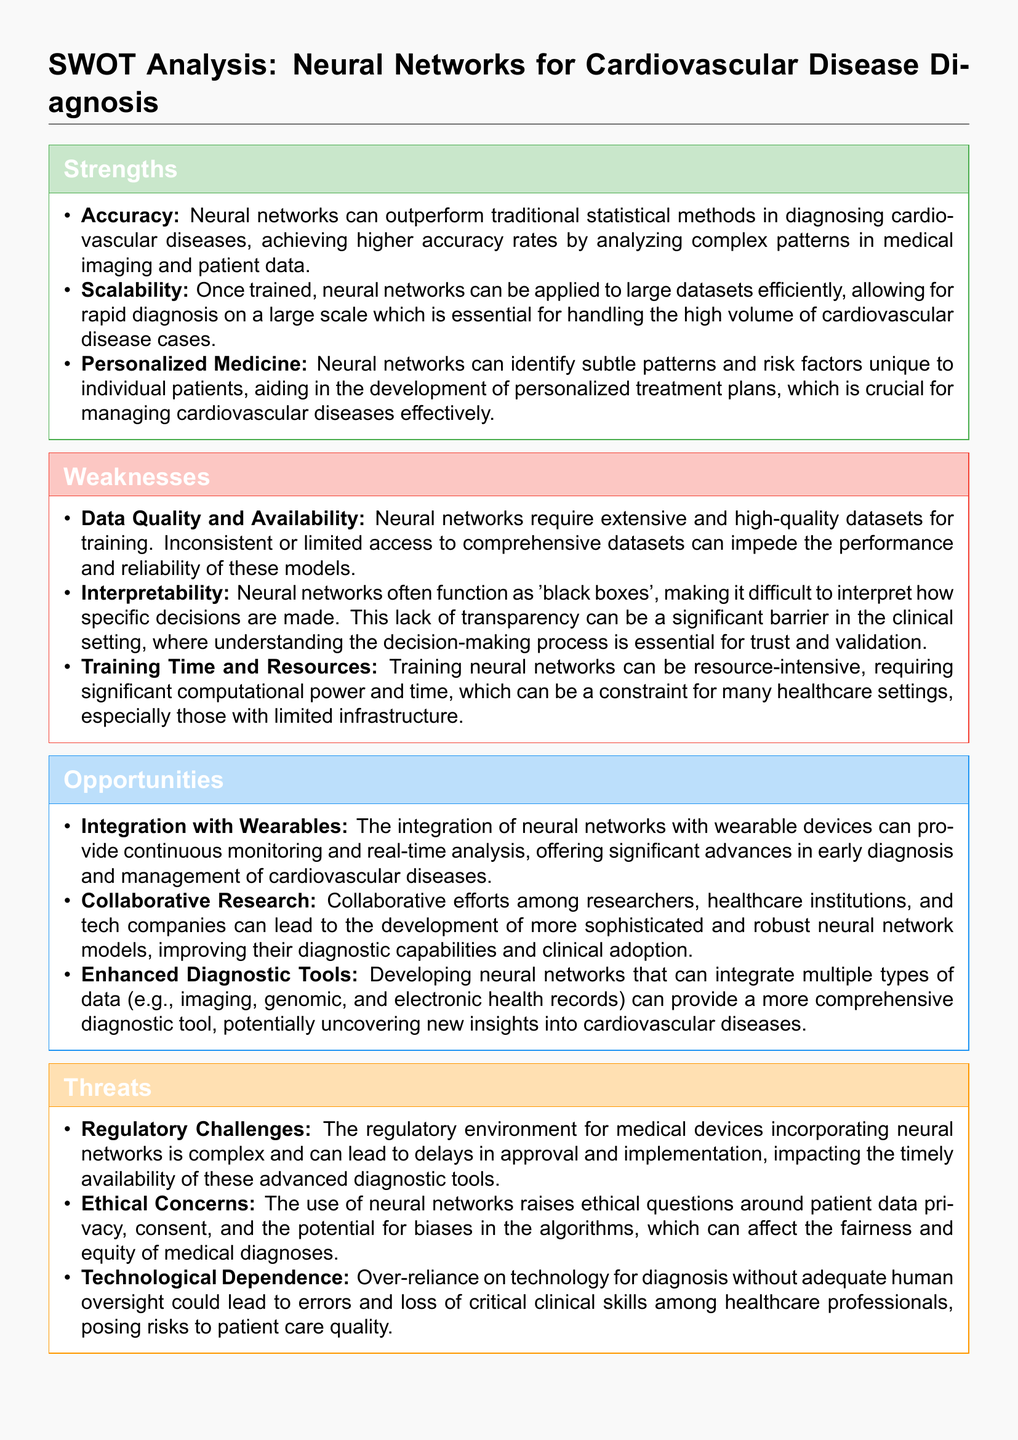What are two strengths of neural networks in cardiovascular disease diagnosis? The strengths listed under the "Strengths" section are accuracy and scalability, which can be retrieved directly from the document.
Answer: accuracy, scalability What is one weakness related to the data used for training neural networks? The document states that data quality and availability are weaknesses, highlighting a need for extensive and high-quality datasets.
Answer: Data Quality and Availability What opportunity is mentioned that involves wearable devices? The document mentions the integration with wearables as an opportunity for continuous monitoring and real-time analysis.
Answer: Integration with Wearables What is the threat associated with patient data in the use of neural networks? The document highlights ethical concerns regarding patient data privacy as a threat.
Answer: Ethical Concerns How many strengths are listed in total? The "Strengths" section of the document lists three strengths of neural networks for diagnosis.
Answer: 3 What is the potential impact of regulatory challenges as mentioned in the document? Regulatory challenges can lead to delays in approval and implementation of diagnostic tools.
Answer: Delays in approval What aspect of decision-making does the weakness of interpretability address? The weakness of interpretability highlights that neural networks can be 'black boxes,' making it difficult to understand their decision-making process.
Answer: Understanding the decision-making process What collaborative opportunity is emphasized in the document? The document emphasizes collaborative research among researchers, healthcare institutions, and tech companies.
Answer: Collaborative Research What core fear is presented regarding technological dependence? The document suggests that over-reliance could lead to errors and loss of critical clinical skills among healthcare professionals.
Answer: Errors and loss of skills 